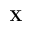<formula> <loc_0><loc_0><loc_500><loc_500>\mathbf X</formula> 